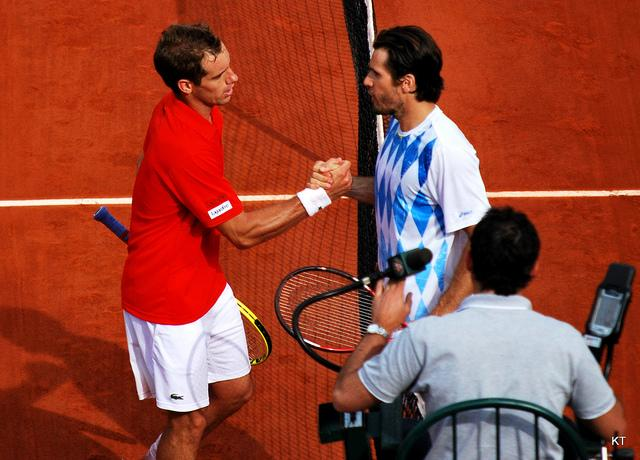What is the man in the chair known as? Please explain your reasoning. referee. The man in the chair is assessing the fairness of the plays as the referee. 